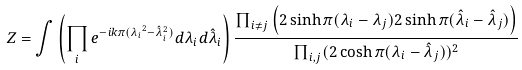<formula> <loc_0><loc_0><loc_500><loc_500>Z = \int \left ( \prod _ { i } e ^ { - i k \pi ( { \lambda _ { i } } ^ { 2 } - \hat { \lambda } _ { i } ^ { 2 } ) } d \lambda _ { i } d \hat { \lambda } _ { i } \right ) \frac { \prod _ { i \neq j } \left ( 2 \sinh \pi ( \lambda _ { i } - \lambda _ { j } ) 2 \sinh \pi ( \hat { \lambda } _ { i } - \hat { \lambda } _ { j } ) \right ) } { \prod _ { i , j } ( 2 \cosh \pi ( \lambda _ { i } - \hat { \lambda } _ { j } ) ) ^ { 2 } }</formula> 